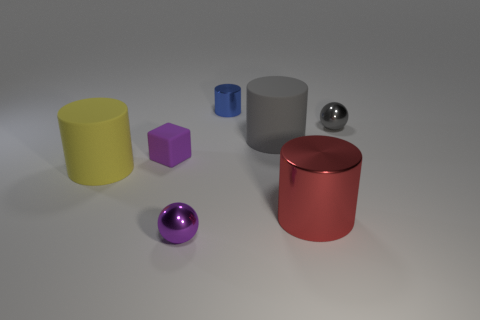Add 1 small purple balls. How many objects exist? 8 Subtract all spheres. How many objects are left? 5 Add 2 cyan rubber objects. How many cyan rubber objects exist? 2 Subtract 0 purple cylinders. How many objects are left? 7 Subtract all large yellow blocks. Subtract all tiny gray metallic things. How many objects are left? 6 Add 4 small blocks. How many small blocks are left? 5 